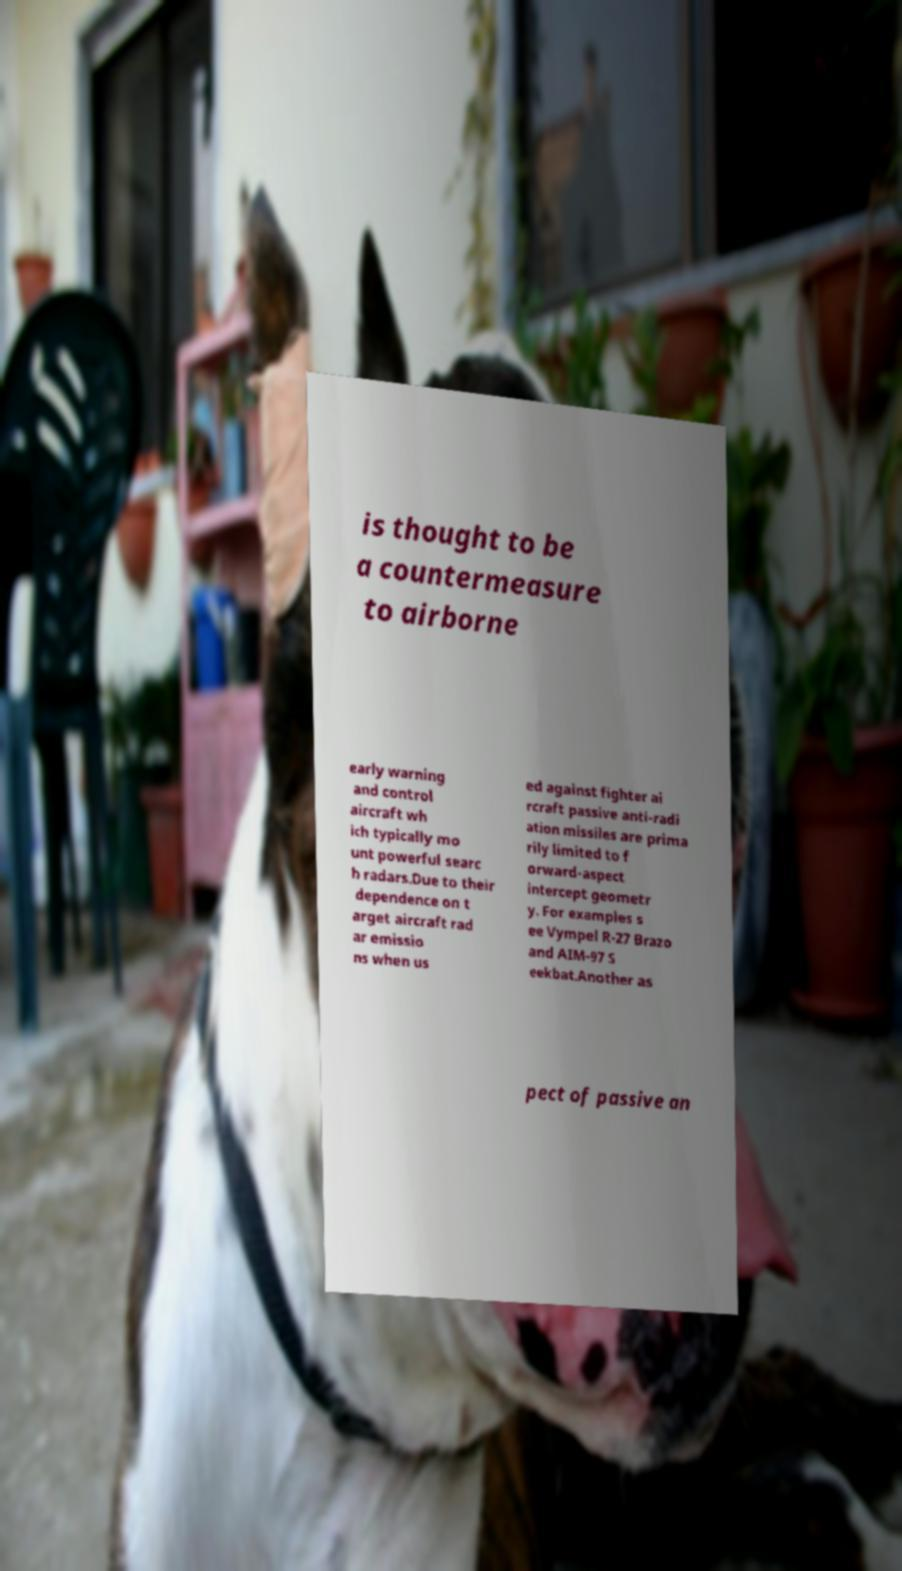There's text embedded in this image that I need extracted. Can you transcribe it verbatim? is thought to be a countermeasure to airborne early warning and control aircraft wh ich typically mo unt powerful searc h radars.Due to their dependence on t arget aircraft rad ar emissio ns when us ed against fighter ai rcraft passive anti-radi ation missiles are prima rily limited to f orward-aspect intercept geometr y. For examples s ee Vympel R-27 Brazo and AIM-97 S eekbat.Another as pect of passive an 